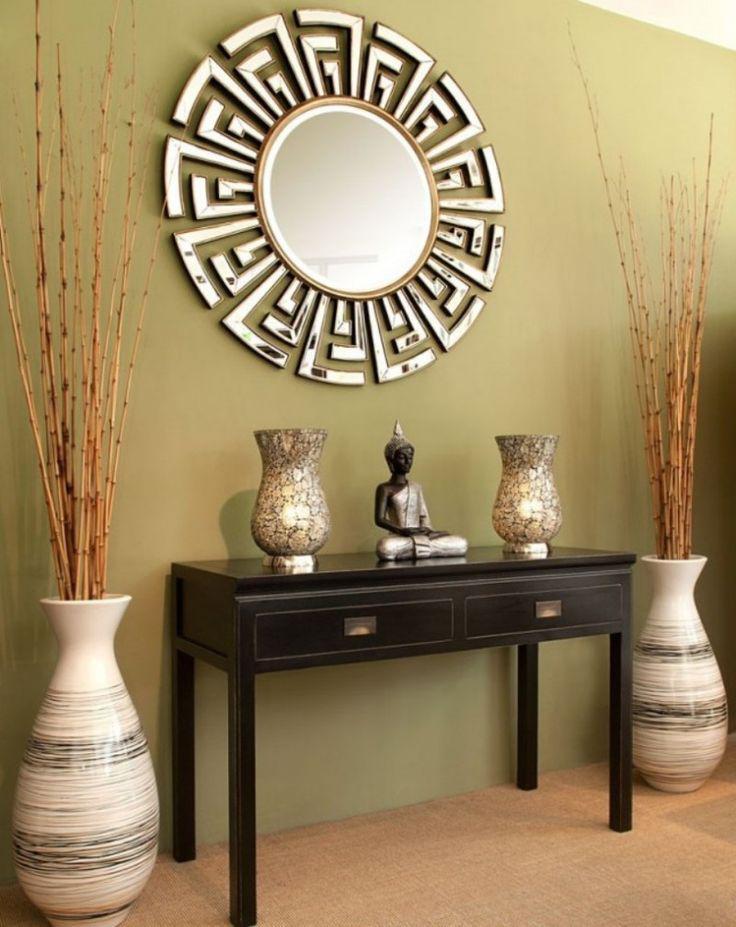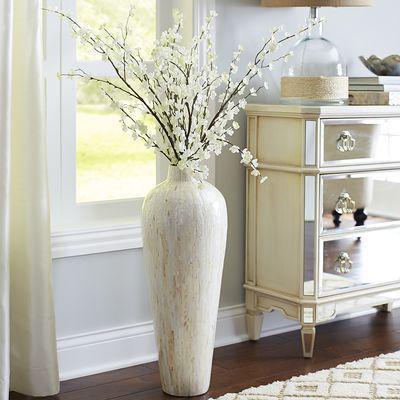The first image is the image on the left, the second image is the image on the right. Evaluate the accuracy of this statement regarding the images: "Each image includes at least one vase that holds branches that extend upward instead of drooping leaves and includes at least one vase that sits on the floor.". Is it true? Answer yes or no. Yes. The first image is the image on the left, the second image is the image on the right. Given the left and right images, does the statement "There are empty vases on a shelf in the image on the left." hold true? Answer yes or no. Yes. 